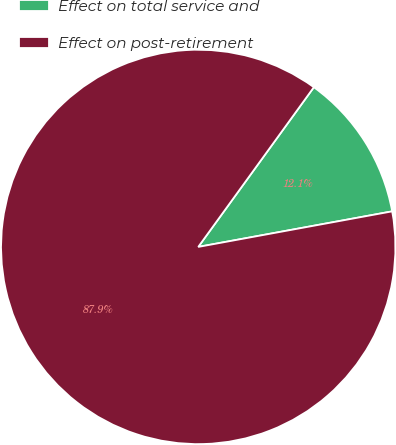<chart> <loc_0><loc_0><loc_500><loc_500><pie_chart><fcel>Effect on total service and<fcel>Effect on post-retirement<nl><fcel>12.14%<fcel>87.86%<nl></chart> 